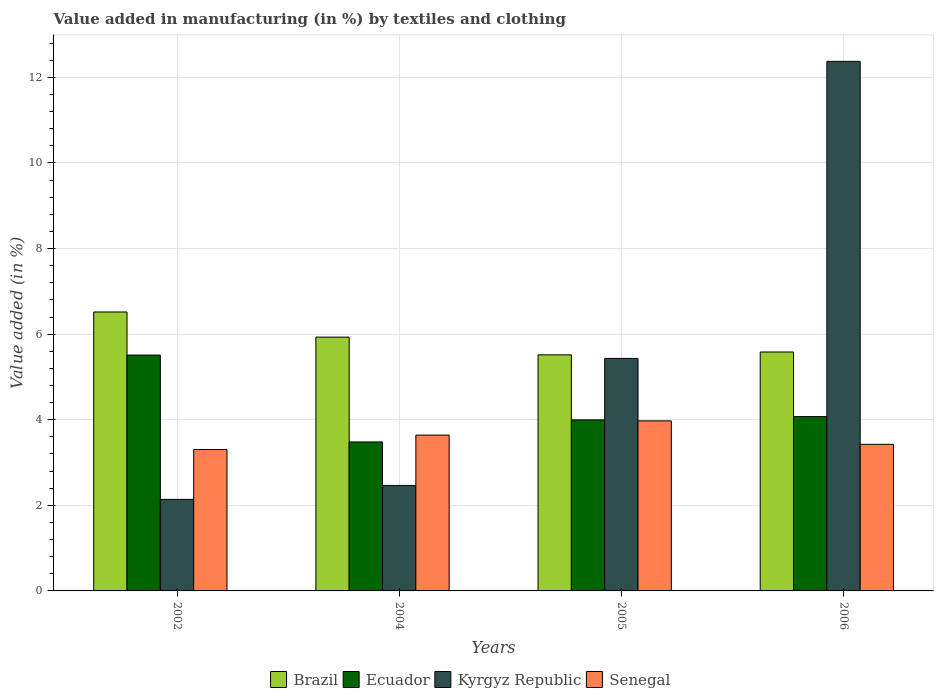How many different coloured bars are there?
Provide a short and direct response. 4. How many groups of bars are there?
Your answer should be very brief. 4. Are the number of bars per tick equal to the number of legend labels?
Give a very brief answer. Yes. Are the number of bars on each tick of the X-axis equal?
Keep it short and to the point. Yes. How many bars are there on the 1st tick from the left?
Provide a short and direct response. 4. In how many cases, is the number of bars for a given year not equal to the number of legend labels?
Ensure brevity in your answer.  0. What is the percentage of value added in manufacturing by textiles and clothing in Senegal in 2006?
Keep it short and to the point. 3.43. Across all years, what is the maximum percentage of value added in manufacturing by textiles and clothing in Senegal?
Your response must be concise. 3.97. Across all years, what is the minimum percentage of value added in manufacturing by textiles and clothing in Kyrgyz Republic?
Your answer should be very brief. 2.14. What is the total percentage of value added in manufacturing by textiles and clothing in Ecuador in the graph?
Your response must be concise. 17.06. What is the difference between the percentage of value added in manufacturing by textiles and clothing in Brazil in 2004 and that in 2006?
Your answer should be compact. 0.35. What is the difference between the percentage of value added in manufacturing by textiles and clothing in Kyrgyz Republic in 2006 and the percentage of value added in manufacturing by textiles and clothing in Ecuador in 2002?
Provide a short and direct response. 6.86. What is the average percentage of value added in manufacturing by textiles and clothing in Brazil per year?
Offer a terse response. 5.89. In the year 2004, what is the difference between the percentage of value added in manufacturing by textiles and clothing in Senegal and percentage of value added in manufacturing by textiles and clothing in Brazil?
Offer a very short reply. -2.29. In how many years, is the percentage of value added in manufacturing by textiles and clothing in Ecuador greater than 1.2000000000000002 %?
Provide a short and direct response. 4. What is the ratio of the percentage of value added in manufacturing by textiles and clothing in Brazil in 2004 to that in 2005?
Ensure brevity in your answer.  1.08. Is the percentage of value added in manufacturing by textiles and clothing in Kyrgyz Republic in 2005 less than that in 2006?
Offer a terse response. Yes. What is the difference between the highest and the second highest percentage of value added in manufacturing by textiles and clothing in Ecuador?
Offer a very short reply. 1.44. What is the difference between the highest and the lowest percentage of value added in manufacturing by textiles and clothing in Ecuador?
Make the answer very short. 2.03. In how many years, is the percentage of value added in manufacturing by textiles and clothing in Senegal greater than the average percentage of value added in manufacturing by textiles and clothing in Senegal taken over all years?
Your answer should be very brief. 2. What does the 3rd bar from the left in 2002 represents?
Make the answer very short. Kyrgyz Republic. Are all the bars in the graph horizontal?
Provide a succinct answer. No. Does the graph contain any zero values?
Provide a short and direct response. No. Does the graph contain grids?
Offer a terse response. Yes. Where does the legend appear in the graph?
Offer a terse response. Bottom center. How many legend labels are there?
Make the answer very short. 4. How are the legend labels stacked?
Offer a very short reply. Horizontal. What is the title of the graph?
Provide a succinct answer. Value added in manufacturing (in %) by textiles and clothing. Does "Fiji" appear as one of the legend labels in the graph?
Give a very brief answer. No. What is the label or title of the X-axis?
Keep it short and to the point. Years. What is the label or title of the Y-axis?
Give a very brief answer. Value added (in %). What is the Value added (in %) of Brazil in 2002?
Keep it short and to the point. 6.52. What is the Value added (in %) of Ecuador in 2002?
Ensure brevity in your answer.  5.51. What is the Value added (in %) in Kyrgyz Republic in 2002?
Offer a very short reply. 2.14. What is the Value added (in %) of Senegal in 2002?
Keep it short and to the point. 3.3. What is the Value added (in %) of Brazil in 2004?
Provide a succinct answer. 5.93. What is the Value added (in %) in Ecuador in 2004?
Provide a short and direct response. 3.48. What is the Value added (in %) in Kyrgyz Republic in 2004?
Provide a short and direct response. 2.46. What is the Value added (in %) in Senegal in 2004?
Provide a succinct answer. 3.64. What is the Value added (in %) of Brazil in 2005?
Provide a short and direct response. 5.52. What is the Value added (in %) in Ecuador in 2005?
Make the answer very short. 4. What is the Value added (in %) of Kyrgyz Republic in 2005?
Your answer should be compact. 5.43. What is the Value added (in %) of Senegal in 2005?
Make the answer very short. 3.97. What is the Value added (in %) in Brazil in 2006?
Give a very brief answer. 5.58. What is the Value added (in %) in Ecuador in 2006?
Provide a succinct answer. 4.07. What is the Value added (in %) of Kyrgyz Republic in 2006?
Give a very brief answer. 12.37. What is the Value added (in %) of Senegal in 2006?
Give a very brief answer. 3.43. Across all years, what is the maximum Value added (in %) in Brazil?
Offer a very short reply. 6.52. Across all years, what is the maximum Value added (in %) of Ecuador?
Provide a succinct answer. 5.51. Across all years, what is the maximum Value added (in %) in Kyrgyz Republic?
Provide a short and direct response. 12.37. Across all years, what is the maximum Value added (in %) of Senegal?
Your response must be concise. 3.97. Across all years, what is the minimum Value added (in %) of Brazil?
Provide a succinct answer. 5.52. Across all years, what is the minimum Value added (in %) of Ecuador?
Give a very brief answer. 3.48. Across all years, what is the minimum Value added (in %) in Kyrgyz Republic?
Offer a very short reply. 2.14. Across all years, what is the minimum Value added (in %) in Senegal?
Ensure brevity in your answer.  3.3. What is the total Value added (in %) in Brazil in the graph?
Make the answer very short. 23.55. What is the total Value added (in %) of Ecuador in the graph?
Provide a succinct answer. 17.06. What is the total Value added (in %) of Kyrgyz Republic in the graph?
Offer a very short reply. 22.41. What is the total Value added (in %) of Senegal in the graph?
Offer a very short reply. 14.34. What is the difference between the Value added (in %) of Brazil in 2002 and that in 2004?
Ensure brevity in your answer.  0.59. What is the difference between the Value added (in %) in Ecuador in 2002 and that in 2004?
Offer a terse response. 2.03. What is the difference between the Value added (in %) of Kyrgyz Republic in 2002 and that in 2004?
Your response must be concise. -0.33. What is the difference between the Value added (in %) in Senegal in 2002 and that in 2004?
Make the answer very short. -0.34. What is the difference between the Value added (in %) of Ecuador in 2002 and that in 2005?
Give a very brief answer. 1.51. What is the difference between the Value added (in %) in Kyrgyz Republic in 2002 and that in 2005?
Offer a terse response. -3.29. What is the difference between the Value added (in %) of Senegal in 2002 and that in 2005?
Offer a very short reply. -0.67. What is the difference between the Value added (in %) of Brazil in 2002 and that in 2006?
Ensure brevity in your answer.  0.94. What is the difference between the Value added (in %) of Ecuador in 2002 and that in 2006?
Offer a very short reply. 1.44. What is the difference between the Value added (in %) of Kyrgyz Republic in 2002 and that in 2006?
Your response must be concise. -10.24. What is the difference between the Value added (in %) in Senegal in 2002 and that in 2006?
Offer a very short reply. -0.12. What is the difference between the Value added (in %) in Brazil in 2004 and that in 2005?
Offer a terse response. 0.41. What is the difference between the Value added (in %) of Ecuador in 2004 and that in 2005?
Make the answer very short. -0.52. What is the difference between the Value added (in %) of Kyrgyz Republic in 2004 and that in 2005?
Make the answer very short. -2.97. What is the difference between the Value added (in %) in Senegal in 2004 and that in 2005?
Make the answer very short. -0.33. What is the difference between the Value added (in %) of Brazil in 2004 and that in 2006?
Make the answer very short. 0.35. What is the difference between the Value added (in %) of Ecuador in 2004 and that in 2006?
Provide a succinct answer. -0.59. What is the difference between the Value added (in %) of Kyrgyz Republic in 2004 and that in 2006?
Make the answer very short. -9.91. What is the difference between the Value added (in %) of Senegal in 2004 and that in 2006?
Offer a terse response. 0.22. What is the difference between the Value added (in %) of Brazil in 2005 and that in 2006?
Your answer should be compact. -0.07. What is the difference between the Value added (in %) of Ecuador in 2005 and that in 2006?
Make the answer very short. -0.08. What is the difference between the Value added (in %) in Kyrgyz Republic in 2005 and that in 2006?
Ensure brevity in your answer.  -6.94. What is the difference between the Value added (in %) in Senegal in 2005 and that in 2006?
Provide a succinct answer. 0.55. What is the difference between the Value added (in %) of Brazil in 2002 and the Value added (in %) of Ecuador in 2004?
Your answer should be compact. 3.04. What is the difference between the Value added (in %) of Brazil in 2002 and the Value added (in %) of Kyrgyz Republic in 2004?
Keep it short and to the point. 4.05. What is the difference between the Value added (in %) in Brazil in 2002 and the Value added (in %) in Senegal in 2004?
Offer a terse response. 2.88. What is the difference between the Value added (in %) in Ecuador in 2002 and the Value added (in %) in Kyrgyz Republic in 2004?
Your answer should be very brief. 3.05. What is the difference between the Value added (in %) of Ecuador in 2002 and the Value added (in %) of Senegal in 2004?
Provide a succinct answer. 1.87. What is the difference between the Value added (in %) in Kyrgyz Republic in 2002 and the Value added (in %) in Senegal in 2004?
Give a very brief answer. -1.5. What is the difference between the Value added (in %) of Brazil in 2002 and the Value added (in %) of Ecuador in 2005?
Your answer should be compact. 2.52. What is the difference between the Value added (in %) of Brazil in 2002 and the Value added (in %) of Kyrgyz Republic in 2005?
Give a very brief answer. 1.09. What is the difference between the Value added (in %) in Brazil in 2002 and the Value added (in %) in Senegal in 2005?
Keep it short and to the point. 2.54. What is the difference between the Value added (in %) of Ecuador in 2002 and the Value added (in %) of Kyrgyz Republic in 2005?
Ensure brevity in your answer.  0.08. What is the difference between the Value added (in %) in Ecuador in 2002 and the Value added (in %) in Senegal in 2005?
Your answer should be compact. 1.54. What is the difference between the Value added (in %) in Kyrgyz Republic in 2002 and the Value added (in %) in Senegal in 2005?
Your answer should be compact. -1.83. What is the difference between the Value added (in %) of Brazil in 2002 and the Value added (in %) of Ecuador in 2006?
Provide a succinct answer. 2.44. What is the difference between the Value added (in %) of Brazil in 2002 and the Value added (in %) of Kyrgyz Republic in 2006?
Your answer should be very brief. -5.86. What is the difference between the Value added (in %) in Brazil in 2002 and the Value added (in %) in Senegal in 2006?
Give a very brief answer. 3.09. What is the difference between the Value added (in %) in Ecuador in 2002 and the Value added (in %) in Kyrgyz Republic in 2006?
Keep it short and to the point. -6.86. What is the difference between the Value added (in %) in Ecuador in 2002 and the Value added (in %) in Senegal in 2006?
Your answer should be very brief. 2.09. What is the difference between the Value added (in %) in Kyrgyz Republic in 2002 and the Value added (in %) in Senegal in 2006?
Make the answer very short. -1.29. What is the difference between the Value added (in %) of Brazil in 2004 and the Value added (in %) of Ecuador in 2005?
Make the answer very short. 1.93. What is the difference between the Value added (in %) of Brazil in 2004 and the Value added (in %) of Kyrgyz Republic in 2005?
Your answer should be compact. 0.5. What is the difference between the Value added (in %) of Brazil in 2004 and the Value added (in %) of Senegal in 2005?
Make the answer very short. 1.96. What is the difference between the Value added (in %) in Ecuador in 2004 and the Value added (in %) in Kyrgyz Republic in 2005?
Give a very brief answer. -1.95. What is the difference between the Value added (in %) of Ecuador in 2004 and the Value added (in %) of Senegal in 2005?
Offer a terse response. -0.49. What is the difference between the Value added (in %) of Kyrgyz Republic in 2004 and the Value added (in %) of Senegal in 2005?
Give a very brief answer. -1.51. What is the difference between the Value added (in %) in Brazil in 2004 and the Value added (in %) in Ecuador in 2006?
Your answer should be very brief. 1.86. What is the difference between the Value added (in %) in Brazil in 2004 and the Value added (in %) in Kyrgyz Republic in 2006?
Offer a very short reply. -6.44. What is the difference between the Value added (in %) of Brazil in 2004 and the Value added (in %) of Senegal in 2006?
Your answer should be compact. 2.51. What is the difference between the Value added (in %) in Ecuador in 2004 and the Value added (in %) in Kyrgyz Republic in 2006?
Provide a succinct answer. -8.89. What is the difference between the Value added (in %) in Ecuador in 2004 and the Value added (in %) in Senegal in 2006?
Provide a succinct answer. 0.06. What is the difference between the Value added (in %) in Kyrgyz Republic in 2004 and the Value added (in %) in Senegal in 2006?
Ensure brevity in your answer.  -0.96. What is the difference between the Value added (in %) in Brazil in 2005 and the Value added (in %) in Ecuador in 2006?
Your response must be concise. 1.44. What is the difference between the Value added (in %) in Brazil in 2005 and the Value added (in %) in Kyrgyz Republic in 2006?
Give a very brief answer. -6.86. What is the difference between the Value added (in %) of Brazil in 2005 and the Value added (in %) of Senegal in 2006?
Give a very brief answer. 2.09. What is the difference between the Value added (in %) in Ecuador in 2005 and the Value added (in %) in Kyrgyz Republic in 2006?
Give a very brief answer. -8.38. What is the difference between the Value added (in %) in Ecuador in 2005 and the Value added (in %) in Senegal in 2006?
Your answer should be very brief. 0.57. What is the difference between the Value added (in %) in Kyrgyz Republic in 2005 and the Value added (in %) in Senegal in 2006?
Make the answer very short. 2.01. What is the average Value added (in %) in Brazil per year?
Make the answer very short. 5.89. What is the average Value added (in %) of Ecuador per year?
Your response must be concise. 4.27. What is the average Value added (in %) of Kyrgyz Republic per year?
Provide a short and direct response. 5.6. What is the average Value added (in %) in Senegal per year?
Your answer should be compact. 3.59. In the year 2002, what is the difference between the Value added (in %) of Brazil and Value added (in %) of Ecuador?
Offer a terse response. 1.01. In the year 2002, what is the difference between the Value added (in %) of Brazil and Value added (in %) of Kyrgyz Republic?
Keep it short and to the point. 4.38. In the year 2002, what is the difference between the Value added (in %) in Brazil and Value added (in %) in Senegal?
Offer a very short reply. 3.21. In the year 2002, what is the difference between the Value added (in %) in Ecuador and Value added (in %) in Kyrgyz Republic?
Provide a short and direct response. 3.37. In the year 2002, what is the difference between the Value added (in %) in Ecuador and Value added (in %) in Senegal?
Offer a very short reply. 2.21. In the year 2002, what is the difference between the Value added (in %) in Kyrgyz Republic and Value added (in %) in Senegal?
Your answer should be very brief. -1.16. In the year 2004, what is the difference between the Value added (in %) of Brazil and Value added (in %) of Ecuador?
Offer a terse response. 2.45. In the year 2004, what is the difference between the Value added (in %) in Brazil and Value added (in %) in Kyrgyz Republic?
Provide a short and direct response. 3.47. In the year 2004, what is the difference between the Value added (in %) of Brazil and Value added (in %) of Senegal?
Ensure brevity in your answer.  2.29. In the year 2004, what is the difference between the Value added (in %) in Ecuador and Value added (in %) in Kyrgyz Republic?
Keep it short and to the point. 1.02. In the year 2004, what is the difference between the Value added (in %) of Ecuador and Value added (in %) of Senegal?
Keep it short and to the point. -0.16. In the year 2004, what is the difference between the Value added (in %) in Kyrgyz Republic and Value added (in %) in Senegal?
Make the answer very short. -1.18. In the year 2005, what is the difference between the Value added (in %) in Brazil and Value added (in %) in Ecuador?
Keep it short and to the point. 1.52. In the year 2005, what is the difference between the Value added (in %) of Brazil and Value added (in %) of Kyrgyz Republic?
Your answer should be very brief. 0.08. In the year 2005, what is the difference between the Value added (in %) of Brazil and Value added (in %) of Senegal?
Give a very brief answer. 1.54. In the year 2005, what is the difference between the Value added (in %) of Ecuador and Value added (in %) of Kyrgyz Republic?
Your answer should be compact. -1.44. In the year 2005, what is the difference between the Value added (in %) in Ecuador and Value added (in %) in Senegal?
Provide a succinct answer. 0.02. In the year 2005, what is the difference between the Value added (in %) in Kyrgyz Republic and Value added (in %) in Senegal?
Your answer should be compact. 1.46. In the year 2006, what is the difference between the Value added (in %) of Brazil and Value added (in %) of Ecuador?
Offer a very short reply. 1.51. In the year 2006, what is the difference between the Value added (in %) of Brazil and Value added (in %) of Kyrgyz Republic?
Provide a short and direct response. -6.79. In the year 2006, what is the difference between the Value added (in %) in Brazil and Value added (in %) in Senegal?
Make the answer very short. 2.16. In the year 2006, what is the difference between the Value added (in %) of Ecuador and Value added (in %) of Kyrgyz Republic?
Provide a succinct answer. -8.3. In the year 2006, what is the difference between the Value added (in %) in Ecuador and Value added (in %) in Senegal?
Your answer should be very brief. 0.65. In the year 2006, what is the difference between the Value added (in %) in Kyrgyz Republic and Value added (in %) in Senegal?
Offer a terse response. 8.95. What is the ratio of the Value added (in %) in Brazil in 2002 to that in 2004?
Your response must be concise. 1.1. What is the ratio of the Value added (in %) of Ecuador in 2002 to that in 2004?
Offer a terse response. 1.58. What is the ratio of the Value added (in %) in Kyrgyz Republic in 2002 to that in 2004?
Give a very brief answer. 0.87. What is the ratio of the Value added (in %) of Senegal in 2002 to that in 2004?
Your answer should be compact. 0.91. What is the ratio of the Value added (in %) in Brazil in 2002 to that in 2005?
Offer a very short reply. 1.18. What is the ratio of the Value added (in %) of Ecuador in 2002 to that in 2005?
Keep it short and to the point. 1.38. What is the ratio of the Value added (in %) in Kyrgyz Republic in 2002 to that in 2005?
Offer a terse response. 0.39. What is the ratio of the Value added (in %) in Senegal in 2002 to that in 2005?
Your response must be concise. 0.83. What is the ratio of the Value added (in %) in Brazil in 2002 to that in 2006?
Your answer should be very brief. 1.17. What is the ratio of the Value added (in %) of Ecuador in 2002 to that in 2006?
Your response must be concise. 1.35. What is the ratio of the Value added (in %) in Kyrgyz Republic in 2002 to that in 2006?
Give a very brief answer. 0.17. What is the ratio of the Value added (in %) of Senegal in 2002 to that in 2006?
Make the answer very short. 0.96. What is the ratio of the Value added (in %) in Brazil in 2004 to that in 2005?
Ensure brevity in your answer.  1.08. What is the ratio of the Value added (in %) of Ecuador in 2004 to that in 2005?
Your answer should be compact. 0.87. What is the ratio of the Value added (in %) in Kyrgyz Republic in 2004 to that in 2005?
Make the answer very short. 0.45. What is the ratio of the Value added (in %) in Senegal in 2004 to that in 2005?
Provide a short and direct response. 0.92. What is the ratio of the Value added (in %) of Brazil in 2004 to that in 2006?
Your answer should be compact. 1.06. What is the ratio of the Value added (in %) in Ecuador in 2004 to that in 2006?
Your answer should be compact. 0.85. What is the ratio of the Value added (in %) of Kyrgyz Republic in 2004 to that in 2006?
Provide a succinct answer. 0.2. What is the ratio of the Value added (in %) in Senegal in 2004 to that in 2006?
Make the answer very short. 1.06. What is the ratio of the Value added (in %) of Ecuador in 2005 to that in 2006?
Your answer should be very brief. 0.98. What is the ratio of the Value added (in %) in Kyrgyz Republic in 2005 to that in 2006?
Offer a very short reply. 0.44. What is the ratio of the Value added (in %) in Senegal in 2005 to that in 2006?
Offer a terse response. 1.16. What is the difference between the highest and the second highest Value added (in %) of Brazil?
Your response must be concise. 0.59. What is the difference between the highest and the second highest Value added (in %) of Ecuador?
Your answer should be very brief. 1.44. What is the difference between the highest and the second highest Value added (in %) of Kyrgyz Republic?
Your answer should be compact. 6.94. What is the difference between the highest and the second highest Value added (in %) of Senegal?
Your answer should be compact. 0.33. What is the difference between the highest and the lowest Value added (in %) in Ecuador?
Provide a succinct answer. 2.03. What is the difference between the highest and the lowest Value added (in %) of Kyrgyz Republic?
Your answer should be compact. 10.24. What is the difference between the highest and the lowest Value added (in %) in Senegal?
Provide a short and direct response. 0.67. 